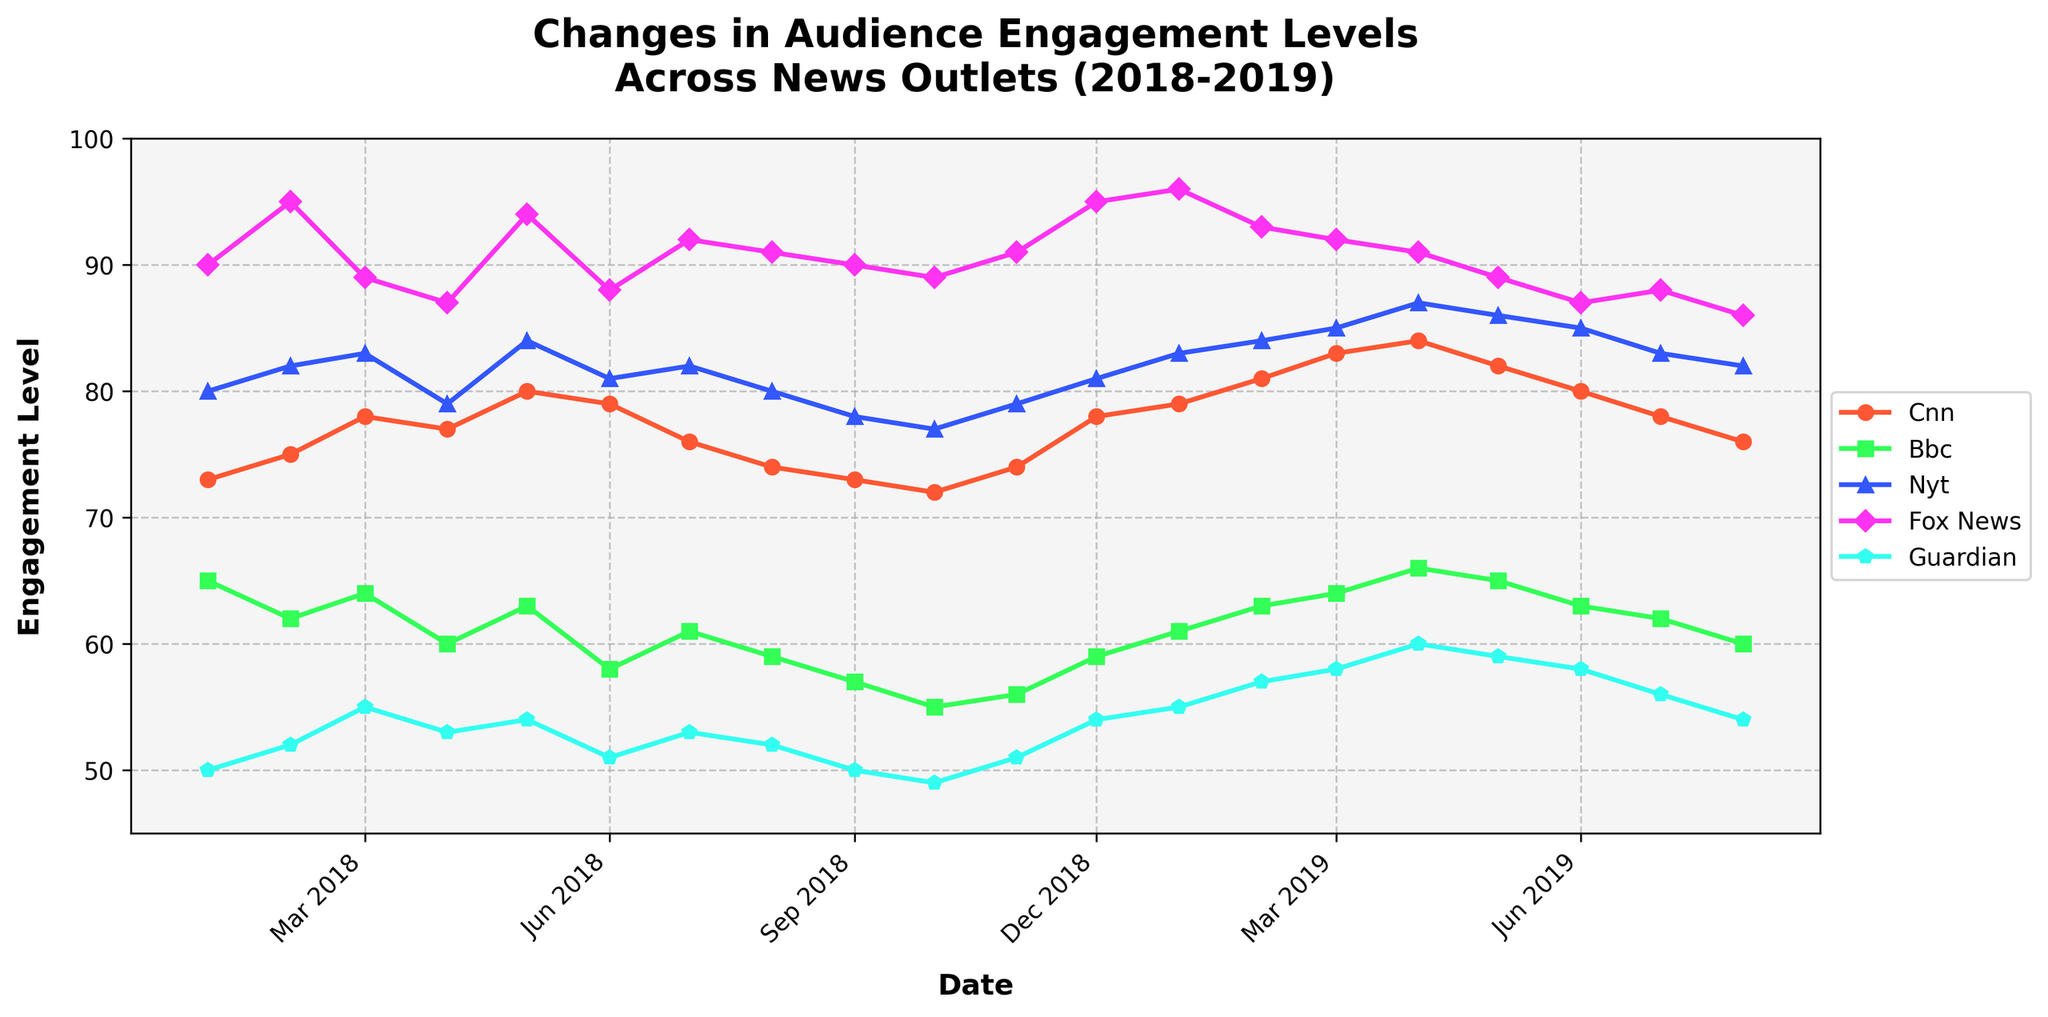What's the title of the figure? The title is located at the top center of the figure, in bold and larger font size, which reads "Changes in Audience Engagement Levels Across News Outlets (2018-2019)".
Answer: Changes in Audience Engagement Levels Across News Outlets (2018-2019) How many news outlets are represented in the plot? By counting the individual lines and checking the legend on the right side of the plot, we can see there are five news outlets represented.
Answer: Five Which news outlet shows the highest engagement level at any point in the timeframe? By examining each line throughout the timeframe, we can see that Fox News reaches the highest engagement level, peaking at around 96 in January 2019.
Answer: Fox News What is the trend of audience engagement for BBC from January 2018 to August 2019? By following the green line representing BBC engagement levels from left to right, we can observe that it starts around 65, decreases, and fluctuates slightly before slightly increasing towards the end of the period.
Answer: Slightly decreasing then stabilizing On which month did CNN have its peak engagement level? By tracing the orange line representing CNN, we can see the peak is in April 2019 where the engagement level reaches about 84.
Answer: April 2019 How does the engagement level of Guardian in August 2019 compare to its level in January 2018? By comparing the blue segment on the left side for January 2018 (around 50) with the left side for August 2019 (around 54), we observe an increase.
Answer: Higher Which news outlet remained the most stable in terms of engagement levels? By examining all lines for fluctuations or changes, the New York Times (represented by the sky blue line) appears the most stable, with slight variations around 80 to 87 throughout.
Answer: New York Times (NYT) What is the average engagement level for Fox News from January 2018 to August 2019? Adding the monthly engagement levels and dividing by the number of months (20), we compute (90+95+89+87+94+88+92+91+90+89+91+95+96+93+92+91+89+87+88+86)/20 = 90.25.
Answer: 90.25 During which period did NYT see a noticeable increase in engagement level? By tracking the sky blue line, a noticeable increase occurs from November 2018 (around 79) to April 2019 (around 87).
Answer: Nov 2018 to Apr 2019 What color represents the Guardian's engagement level, and how can you identify it? The colors can be identified by their corresponding lines in the plot and the legend. The Guardian is represented by the cyan line.
Answer: Cyan 